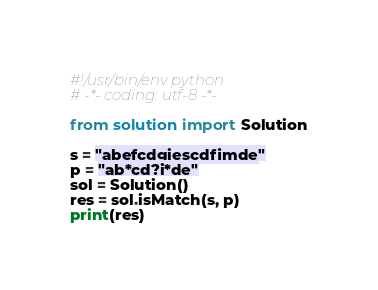Convert code to text. <code><loc_0><loc_0><loc_500><loc_500><_Python_>#!/usr/bin/env python
# -*- coding: utf-8 -*-

from solution import Solution

s = "abefcdgiescdfimde"
p = "ab*cd?i*de"
sol = Solution()
res = sol.isMatch(s, p)
print(res)
</code> 